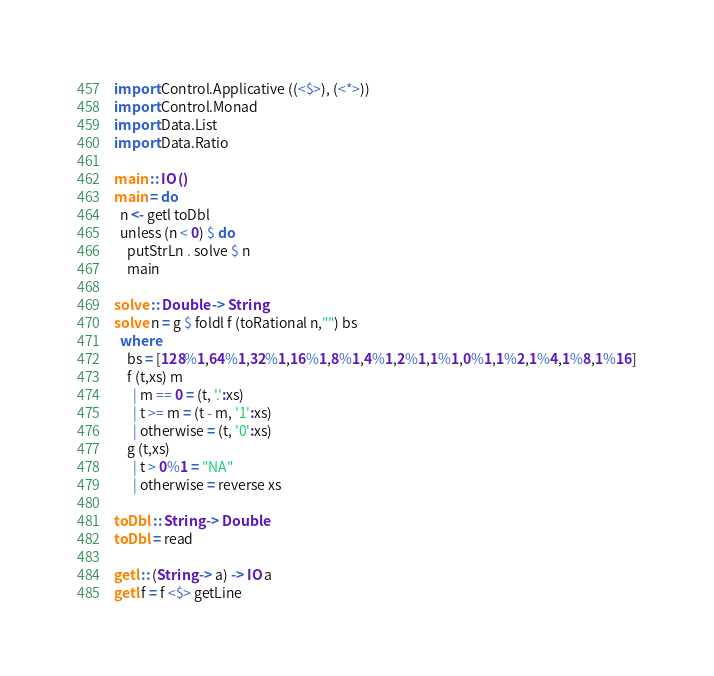<code> <loc_0><loc_0><loc_500><loc_500><_Haskell_>import Control.Applicative ((<$>), (<*>))
import Control.Monad
import Data.List
import Data.Ratio

main :: IO ()
main = do
  n <- getl toDbl
  unless (n < 0) $ do
    putStrLn . solve $ n
    main

solve :: Double -> String
solve n = g $ foldl f (toRational n,"") bs
  where
    bs = [128%1,64%1,32%1,16%1,8%1,4%1,2%1,1%1,0%1,1%2,1%4,1%8,1%16]
    f (t,xs) m
      | m == 0 = (t, '.':xs)
      | t >= m = (t - m, '1':xs)
      | otherwise = (t, '0':xs)
    g (t,xs)
      | t > 0%1 = "NA"
      | otherwise = reverse xs
    
toDbl :: String -> Double
toDbl = read

getl :: (String -> a) -> IO a
getl f = f <$> getLine</code> 